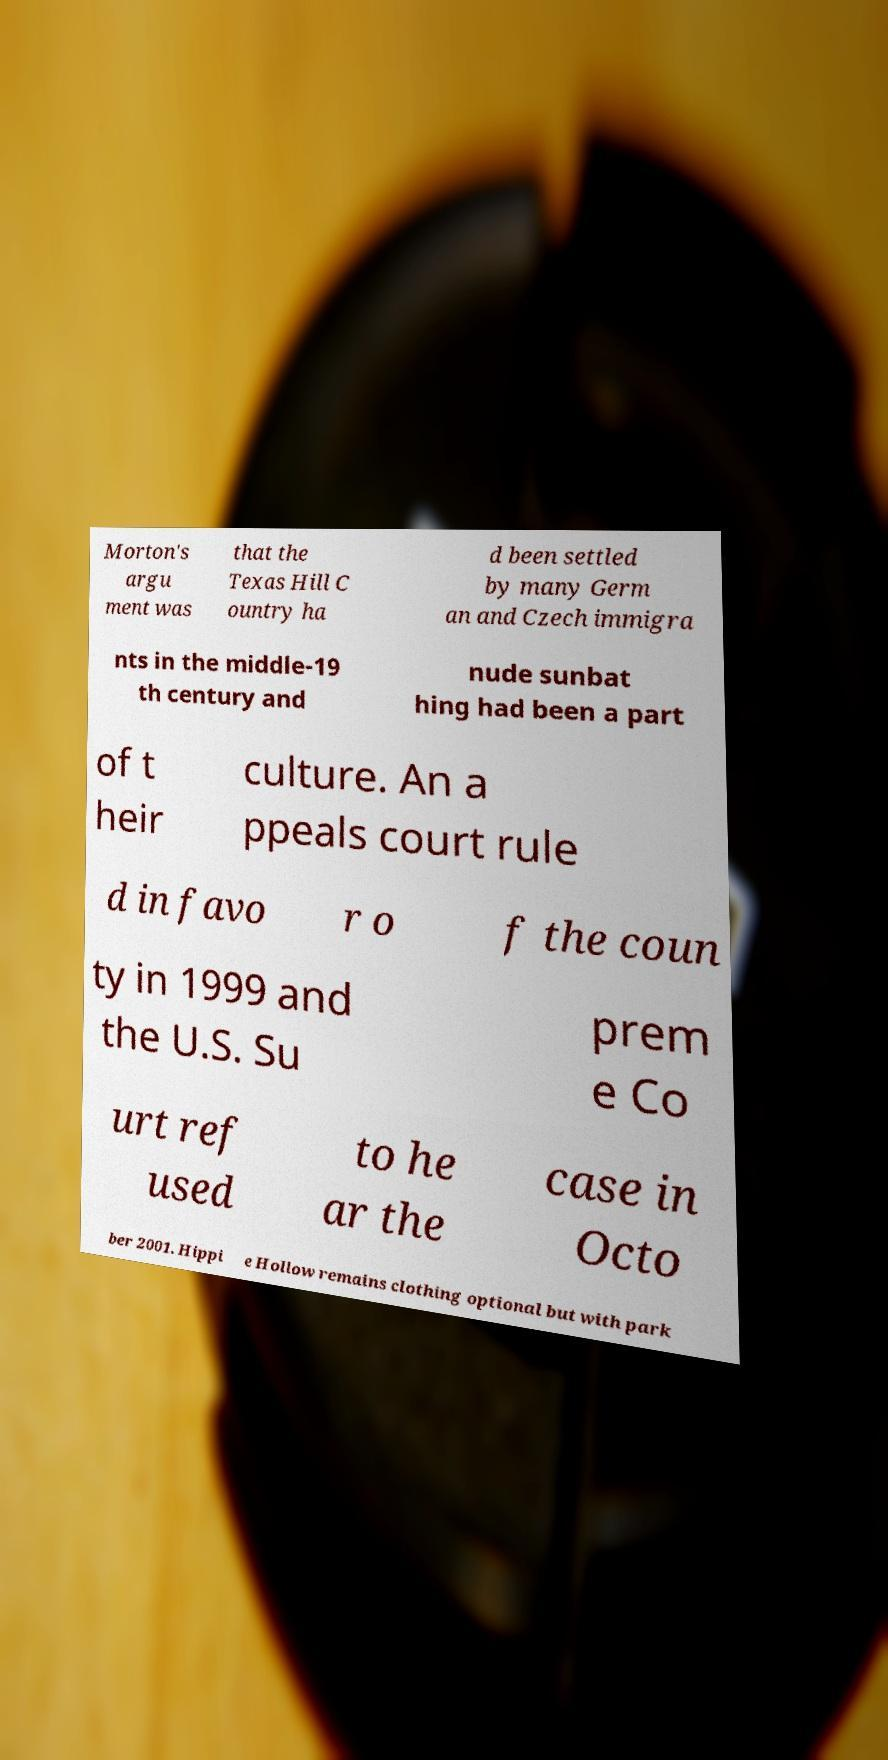There's text embedded in this image that I need extracted. Can you transcribe it verbatim? Morton's argu ment was that the Texas Hill C ountry ha d been settled by many Germ an and Czech immigra nts in the middle-19 th century and nude sunbat hing had been a part of t heir culture. An a ppeals court rule d in favo r o f the coun ty in 1999 and the U.S. Su prem e Co urt ref used to he ar the case in Octo ber 2001. Hippi e Hollow remains clothing optional but with park 